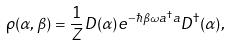Convert formula to latex. <formula><loc_0><loc_0><loc_500><loc_500>\rho ( \alpha , \beta ) = { \frac { 1 } { Z } } D ( \alpha ) e ^ { - \hbar { \beta } \omega a ^ { \dagger } a } D ^ { \dagger } ( \alpha ) ,</formula> 